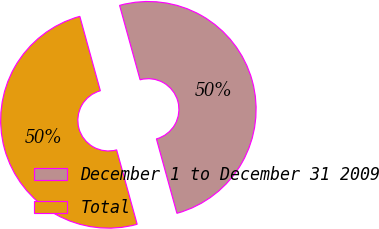Convert chart. <chart><loc_0><loc_0><loc_500><loc_500><pie_chart><fcel>December 1 to December 31 2009<fcel>Total<nl><fcel>50.0%<fcel>50.0%<nl></chart> 